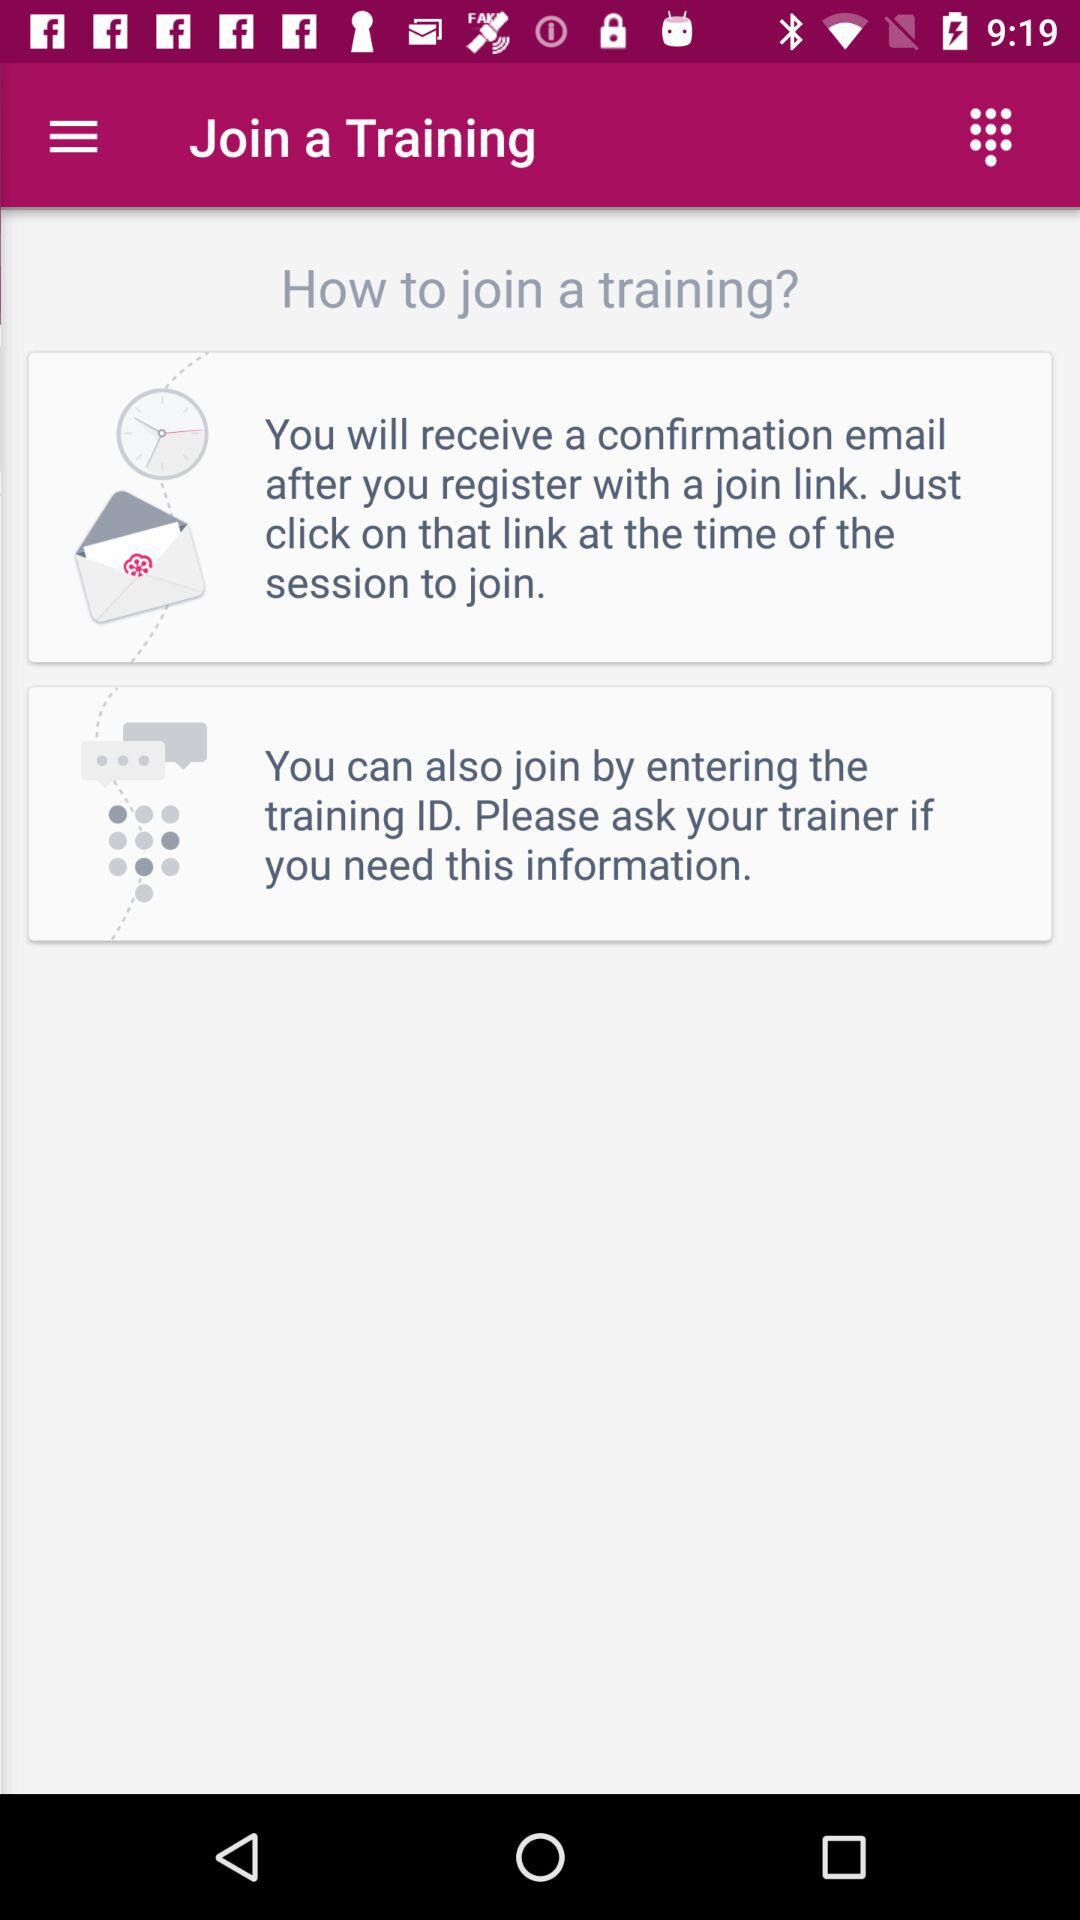How many ways can I join a training?
Answer the question using a single word or phrase. 2 